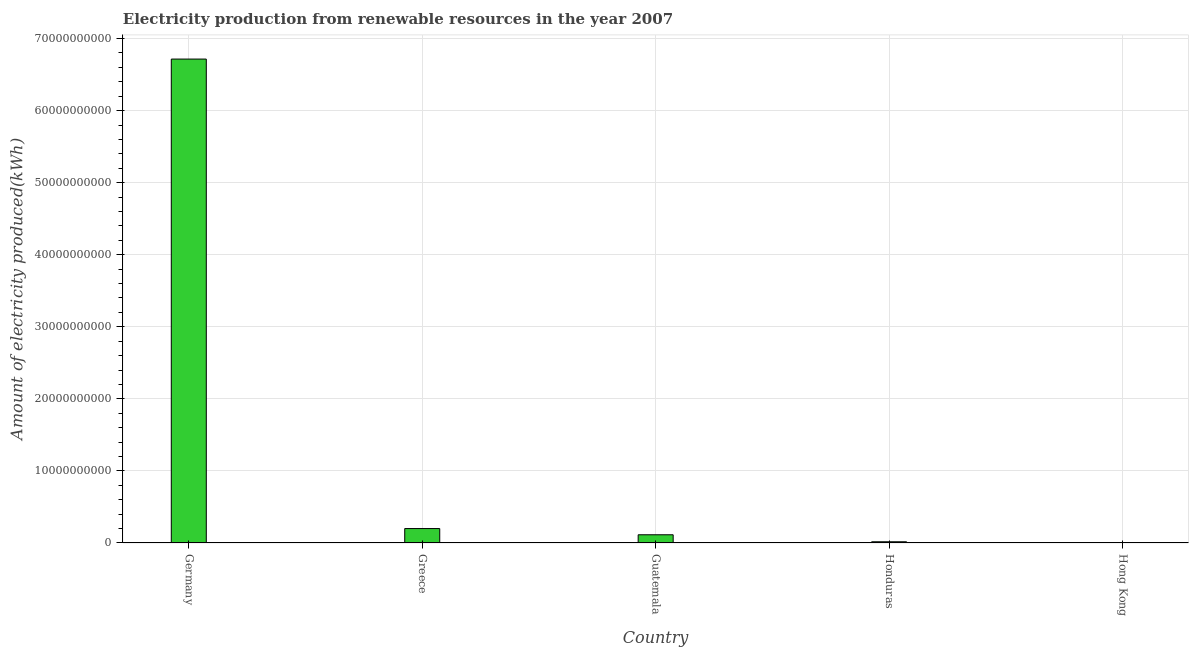Does the graph contain grids?
Your answer should be compact. Yes. What is the title of the graph?
Your answer should be compact. Electricity production from renewable resources in the year 2007. What is the label or title of the X-axis?
Ensure brevity in your answer.  Country. What is the label or title of the Y-axis?
Your response must be concise. Amount of electricity produced(kWh). What is the amount of electricity produced in Guatemala?
Provide a succinct answer. 1.14e+09. Across all countries, what is the maximum amount of electricity produced?
Offer a very short reply. 6.72e+1. Across all countries, what is the minimum amount of electricity produced?
Keep it short and to the point. 1.00e+06. In which country was the amount of electricity produced maximum?
Offer a terse response. Germany. In which country was the amount of electricity produced minimum?
Your answer should be compact. Hong Kong. What is the sum of the amount of electricity produced?
Ensure brevity in your answer.  7.05e+1. What is the difference between the amount of electricity produced in Guatemala and Hong Kong?
Make the answer very short. 1.14e+09. What is the average amount of electricity produced per country?
Your answer should be very brief. 1.41e+1. What is the median amount of electricity produced?
Provide a short and direct response. 1.14e+09. In how many countries, is the amount of electricity produced greater than 48000000000 kWh?
Keep it short and to the point. 1. What is the ratio of the amount of electricity produced in Greece to that in Hong Kong?
Make the answer very short. 2003. Is the amount of electricity produced in Greece less than that in Hong Kong?
Make the answer very short. No. Is the difference between the amount of electricity produced in Germany and Guatemala greater than the difference between any two countries?
Your answer should be very brief. No. What is the difference between the highest and the second highest amount of electricity produced?
Offer a terse response. 6.51e+1. What is the difference between the highest and the lowest amount of electricity produced?
Make the answer very short. 6.72e+1. How many countries are there in the graph?
Provide a short and direct response. 5. What is the difference between two consecutive major ticks on the Y-axis?
Offer a very short reply. 1.00e+1. What is the Amount of electricity produced(kWh) of Germany?
Offer a terse response. 6.72e+1. What is the Amount of electricity produced(kWh) in Greece?
Offer a terse response. 2.00e+09. What is the Amount of electricity produced(kWh) of Guatemala?
Give a very brief answer. 1.14e+09. What is the Amount of electricity produced(kWh) of Honduras?
Provide a short and direct response. 1.68e+08. What is the difference between the Amount of electricity produced(kWh) in Germany and Greece?
Your answer should be compact. 6.51e+1. What is the difference between the Amount of electricity produced(kWh) in Germany and Guatemala?
Your answer should be compact. 6.60e+1. What is the difference between the Amount of electricity produced(kWh) in Germany and Honduras?
Your answer should be compact. 6.70e+1. What is the difference between the Amount of electricity produced(kWh) in Germany and Hong Kong?
Offer a very short reply. 6.72e+1. What is the difference between the Amount of electricity produced(kWh) in Greece and Guatemala?
Your answer should be very brief. 8.64e+08. What is the difference between the Amount of electricity produced(kWh) in Greece and Honduras?
Your answer should be very brief. 1.84e+09. What is the difference between the Amount of electricity produced(kWh) in Greece and Hong Kong?
Ensure brevity in your answer.  2.00e+09. What is the difference between the Amount of electricity produced(kWh) in Guatemala and Honduras?
Your answer should be very brief. 9.71e+08. What is the difference between the Amount of electricity produced(kWh) in Guatemala and Hong Kong?
Make the answer very short. 1.14e+09. What is the difference between the Amount of electricity produced(kWh) in Honduras and Hong Kong?
Make the answer very short. 1.67e+08. What is the ratio of the Amount of electricity produced(kWh) in Germany to that in Greece?
Make the answer very short. 33.52. What is the ratio of the Amount of electricity produced(kWh) in Germany to that in Guatemala?
Provide a short and direct response. 58.96. What is the ratio of the Amount of electricity produced(kWh) in Germany to that in Honduras?
Your answer should be compact. 399.71. What is the ratio of the Amount of electricity produced(kWh) in Germany to that in Hong Kong?
Your answer should be very brief. 6.72e+04. What is the ratio of the Amount of electricity produced(kWh) in Greece to that in Guatemala?
Offer a very short reply. 1.76. What is the ratio of the Amount of electricity produced(kWh) in Greece to that in Honduras?
Provide a succinct answer. 11.92. What is the ratio of the Amount of electricity produced(kWh) in Greece to that in Hong Kong?
Your response must be concise. 2003. What is the ratio of the Amount of electricity produced(kWh) in Guatemala to that in Honduras?
Provide a succinct answer. 6.78. What is the ratio of the Amount of electricity produced(kWh) in Guatemala to that in Hong Kong?
Your answer should be very brief. 1139. What is the ratio of the Amount of electricity produced(kWh) in Honduras to that in Hong Kong?
Ensure brevity in your answer.  168. 